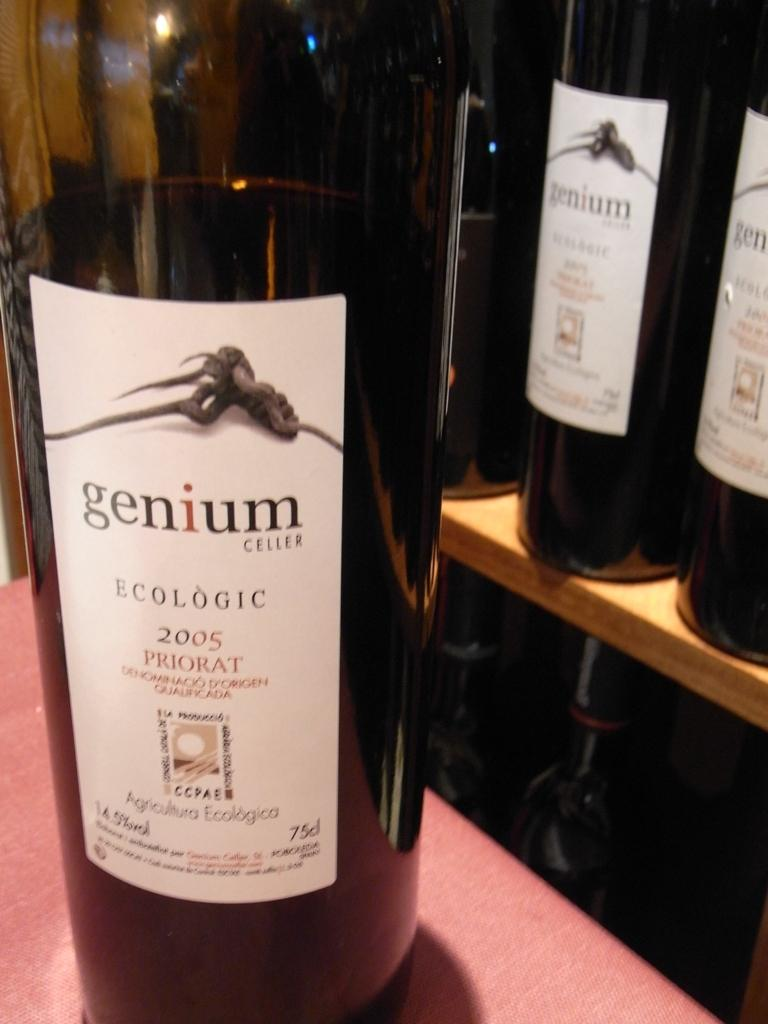<image>
Present a compact description of the photo's key features. Three bottles of red wine from the maker Genium Cellar. 